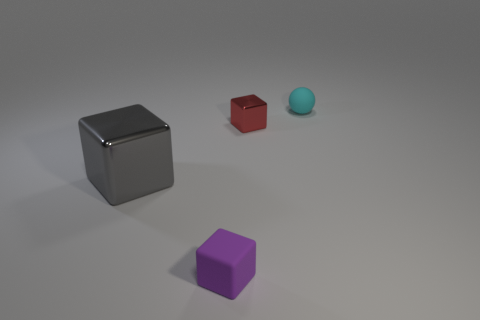Add 1 red shiny balls. How many objects exist? 5 Subtract all blocks. How many objects are left? 1 Add 3 purple metallic things. How many purple metallic things exist? 3 Subtract 0 blue balls. How many objects are left? 4 Subtract all cyan rubber things. Subtract all small metal cubes. How many objects are left? 2 Add 1 balls. How many balls are left? 2 